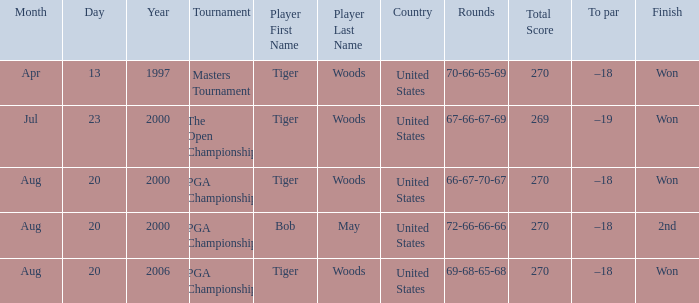What country hosts the tournament the open championship? United States. 